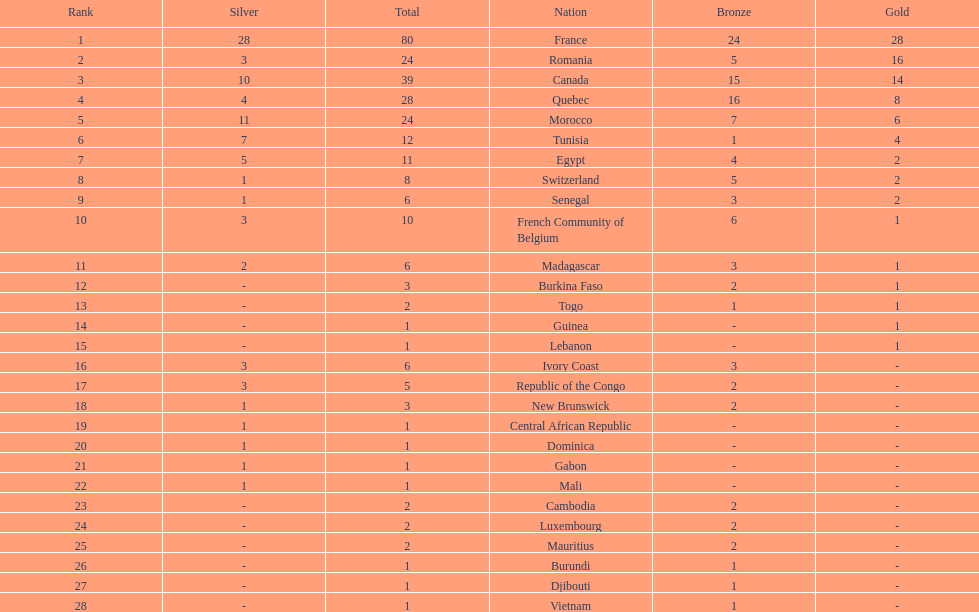What is the difference between france's and egypt's silver medals? 23. 